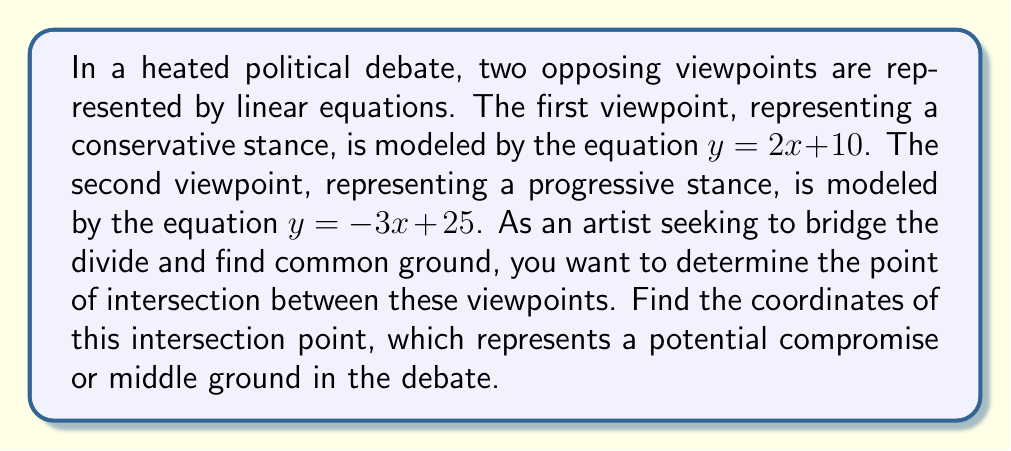What is the answer to this math problem? To find the intersection point of these two linear equations, we need to solve the system of equations:

$$\begin{cases}
y = 2x + 10 \\
y = -3x + 25
\end{cases}$$

Step 1: Since both equations are equal to $y$, we can set them equal to each other:
$$2x + 10 = -3x + 25$$

Step 2: Solve for $x$ by adding $3x$ to both sides and subtracting 10 from both sides:
$$5x = 15$$

Step 3: Divide both sides by 5:
$$x = 3$$

Step 4: Now that we know $x$, we can substitute this value into either of the original equations to find $y$. Let's use the first equation:

$$\begin{align}
y &= 2x + 10 \\
y &= 2(3) + 10 \\
y &= 6 + 10 \\
y &= 16
\end{align}$$

Therefore, the point of intersection is $(3, 16)$.

This point represents where the two viewpoints align or find common ground. In the context of the debate, this could symbolize a potential compromise or a shared perspective that both sides might agree upon, despite their otherwise opposing views.
Answer: The point of intersection is $(3, 16)$. 